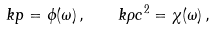Convert formula to latex. <formula><loc_0><loc_0><loc_500><loc_500>k p = \phi ( \omega ) \, , \quad k \rho c ^ { 2 } = \chi ( \omega ) \, ,</formula> 